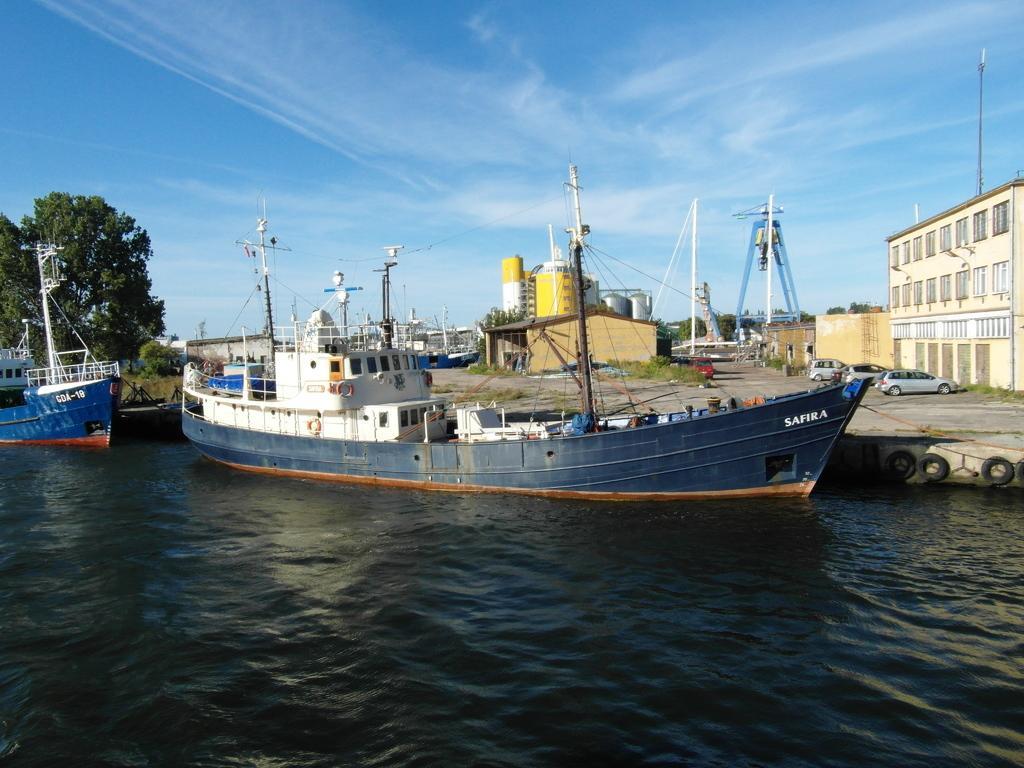How would you summarize this image in a sentence or two? In this picture we can observe two ships floating on the water near the dock. There are two buildings. We can observe some cars parked on the right side. There are some poles. In the background there are trees and a sky with some clouds. 